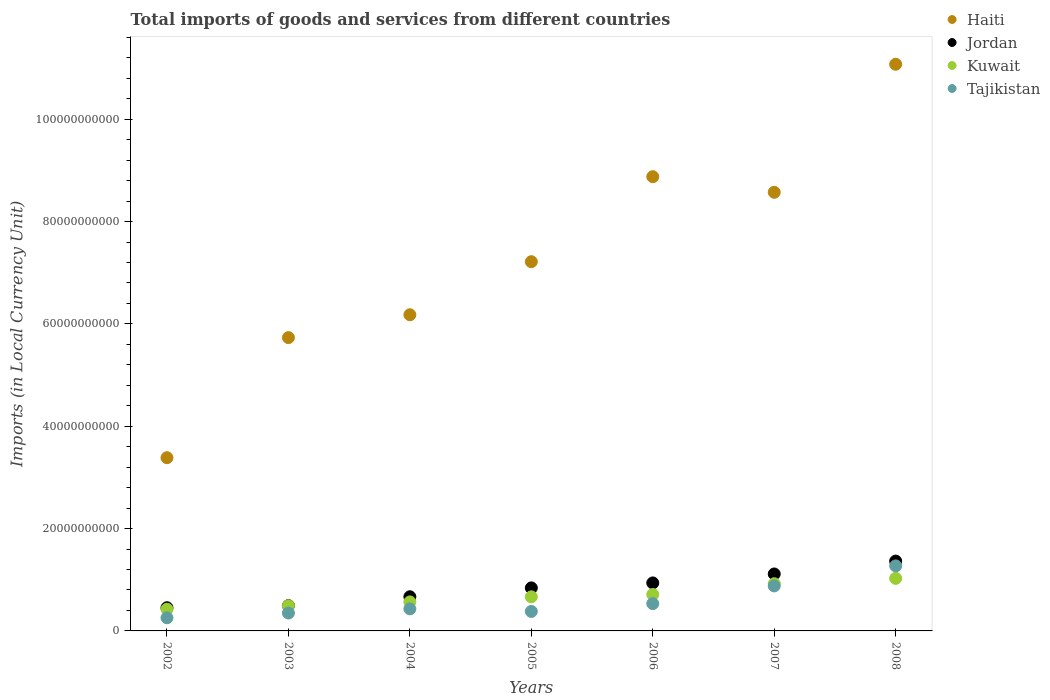Is the number of dotlines equal to the number of legend labels?
Your answer should be compact. Yes. What is the Amount of goods and services imports in Haiti in 2007?
Your response must be concise. 8.57e+1. Across all years, what is the maximum Amount of goods and services imports in Haiti?
Keep it short and to the point. 1.11e+11. Across all years, what is the minimum Amount of goods and services imports in Tajikistan?
Keep it short and to the point. 2.57e+09. In which year was the Amount of goods and services imports in Jordan maximum?
Provide a succinct answer. 2008. In which year was the Amount of goods and services imports in Haiti minimum?
Your answer should be compact. 2002. What is the total Amount of goods and services imports in Haiti in the graph?
Provide a succinct answer. 5.10e+11. What is the difference between the Amount of goods and services imports in Tajikistan in 2003 and that in 2008?
Keep it short and to the point. -9.21e+09. What is the difference between the Amount of goods and services imports in Tajikistan in 2003 and the Amount of goods and services imports in Haiti in 2007?
Your response must be concise. -8.22e+1. What is the average Amount of goods and services imports in Kuwait per year?
Offer a terse response. 6.87e+09. In the year 2006, what is the difference between the Amount of goods and services imports in Jordan and Amount of goods and services imports in Kuwait?
Provide a short and direct response. 2.26e+09. In how many years, is the Amount of goods and services imports in Jordan greater than 88000000000 LCU?
Ensure brevity in your answer.  0. What is the ratio of the Amount of goods and services imports in Tajikistan in 2002 to that in 2007?
Provide a short and direct response. 0.29. Is the difference between the Amount of goods and services imports in Jordan in 2002 and 2004 greater than the difference between the Amount of goods and services imports in Kuwait in 2002 and 2004?
Keep it short and to the point. No. What is the difference between the highest and the second highest Amount of goods and services imports in Haiti?
Your answer should be very brief. 2.20e+1. What is the difference between the highest and the lowest Amount of goods and services imports in Kuwait?
Offer a very short reply. 6.03e+09. Is it the case that in every year, the sum of the Amount of goods and services imports in Kuwait and Amount of goods and services imports in Tajikistan  is greater than the sum of Amount of goods and services imports in Jordan and Amount of goods and services imports in Haiti?
Keep it short and to the point. No. Is the Amount of goods and services imports in Jordan strictly greater than the Amount of goods and services imports in Tajikistan over the years?
Give a very brief answer. Yes. Is the Amount of goods and services imports in Haiti strictly less than the Amount of goods and services imports in Tajikistan over the years?
Provide a short and direct response. No. How many dotlines are there?
Offer a very short reply. 4. What is the difference between two consecutive major ticks on the Y-axis?
Make the answer very short. 2.00e+1. Are the values on the major ticks of Y-axis written in scientific E-notation?
Keep it short and to the point. No. What is the title of the graph?
Your answer should be compact. Total imports of goods and services from different countries. What is the label or title of the Y-axis?
Provide a short and direct response. Imports (in Local Currency Unit). What is the Imports (in Local Currency Unit) in Haiti in 2002?
Make the answer very short. 3.39e+1. What is the Imports (in Local Currency Unit) in Jordan in 2002?
Your answer should be very brief. 4.53e+09. What is the Imports (in Local Currency Unit) in Kuwait in 2002?
Offer a terse response. 4.24e+09. What is the Imports (in Local Currency Unit) of Tajikistan in 2002?
Provide a succinct answer. 2.57e+09. What is the Imports (in Local Currency Unit) in Haiti in 2003?
Make the answer very short. 5.73e+1. What is the Imports (in Local Currency Unit) of Jordan in 2003?
Offer a very short reply. 4.95e+09. What is the Imports (in Local Currency Unit) of Kuwait in 2003?
Offer a terse response. 4.92e+09. What is the Imports (in Local Currency Unit) of Tajikistan in 2003?
Ensure brevity in your answer.  3.50e+09. What is the Imports (in Local Currency Unit) of Haiti in 2004?
Offer a terse response. 6.18e+1. What is the Imports (in Local Currency Unit) in Jordan in 2004?
Provide a short and direct response. 6.68e+09. What is the Imports (in Local Currency Unit) of Kuwait in 2004?
Provide a short and direct response. 5.67e+09. What is the Imports (in Local Currency Unit) of Tajikistan in 2004?
Give a very brief answer. 4.31e+09. What is the Imports (in Local Currency Unit) in Haiti in 2005?
Your answer should be compact. 7.22e+1. What is the Imports (in Local Currency Unit) of Jordan in 2005?
Offer a very short reply. 8.41e+09. What is the Imports (in Local Currency Unit) of Kuwait in 2005?
Your answer should be very brief. 6.67e+09. What is the Imports (in Local Currency Unit) in Tajikistan in 2005?
Your answer should be very brief. 3.81e+09. What is the Imports (in Local Currency Unit) in Haiti in 2006?
Give a very brief answer. 8.88e+1. What is the Imports (in Local Currency Unit) in Jordan in 2006?
Your response must be concise. 9.38e+09. What is the Imports (in Local Currency Unit) of Kuwait in 2006?
Ensure brevity in your answer.  7.12e+09. What is the Imports (in Local Currency Unit) of Tajikistan in 2006?
Offer a very short reply. 5.34e+09. What is the Imports (in Local Currency Unit) of Haiti in 2007?
Offer a very short reply. 8.57e+1. What is the Imports (in Local Currency Unit) of Jordan in 2007?
Your response must be concise. 1.11e+1. What is the Imports (in Local Currency Unit) of Kuwait in 2007?
Keep it short and to the point. 9.23e+09. What is the Imports (in Local Currency Unit) of Tajikistan in 2007?
Offer a terse response. 8.79e+09. What is the Imports (in Local Currency Unit) of Haiti in 2008?
Provide a short and direct response. 1.11e+11. What is the Imports (in Local Currency Unit) of Jordan in 2008?
Provide a short and direct response. 1.36e+1. What is the Imports (in Local Currency Unit) of Kuwait in 2008?
Offer a terse response. 1.03e+1. What is the Imports (in Local Currency Unit) in Tajikistan in 2008?
Offer a very short reply. 1.27e+1. Across all years, what is the maximum Imports (in Local Currency Unit) in Haiti?
Offer a very short reply. 1.11e+11. Across all years, what is the maximum Imports (in Local Currency Unit) of Jordan?
Make the answer very short. 1.36e+1. Across all years, what is the maximum Imports (in Local Currency Unit) in Kuwait?
Your response must be concise. 1.03e+1. Across all years, what is the maximum Imports (in Local Currency Unit) of Tajikistan?
Ensure brevity in your answer.  1.27e+1. Across all years, what is the minimum Imports (in Local Currency Unit) in Haiti?
Your answer should be compact. 3.39e+1. Across all years, what is the minimum Imports (in Local Currency Unit) of Jordan?
Offer a very short reply. 4.53e+09. Across all years, what is the minimum Imports (in Local Currency Unit) in Kuwait?
Offer a terse response. 4.24e+09. Across all years, what is the minimum Imports (in Local Currency Unit) in Tajikistan?
Give a very brief answer. 2.57e+09. What is the total Imports (in Local Currency Unit) in Haiti in the graph?
Offer a very short reply. 5.10e+11. What is the total Imports (in Local Currency Unit) in Jordan in the graph?
Your answer should be very brief. 5.87e+1. What is the total Imports (in Local Currency Unit) of Kuwait in the graph?
Your response must be concise. 4.81e+1. What is the total Imports (in Local Currency Unit) in Tajikistan in the graph?
Give a very brief answer. 4.10e+1. What is the difference between the Imports (in Local Currency Unit) in Haiti in 2002 and that in 2003?
Your answer should be compact. -2.35e+1. What is the difference between the Imports (in Local Currency Unit) of Jordan in 2002 and that in 2003?
Your answer should be very brief. -4.14e+08. What is the difference between the Imports (in Local Currency Unit) in Kuwait in 2002 and that in 2003?
Make the answer very short. -6.74e+08. What is the difference between the Imports (in Local Currency Unit) in Tajikistan in 2002 and that in 2003?
Make the answer very short. -9.28e+08. What is the difference between the Imports (in Local Currency Unit) of Haiti in 2002 and that in 2004?
Offer a terse response. -2.79e+1. What is the difference between the Imports (in Local Currency Unit) of Jordan in 2002 and that in 2004?
Provide a short and direct response. -2.15e+09. What is the difference between the Imports (in Local Currency Unit) in Kuwait in 2002 and that in 2004?
Make the answer very short. -1.43e+09. What is the difference between the Imports (in Local Currency Unit) of Tajikistan in 2002 and that in 2004?
Your answer should be compact. -1.74e+09. What is the difference between the Imports (in Local Currency Unit) in Haiti in 2002 and that in 2005?
Give a very brief answer. -3.83e+1. What is the difference between the Imports (in Local Currency Unit) in Jordan in 2002 and that in 2005?
Provide a succinct answer. -3.88e+09. What is the difference between the Imports (in Local Currency Unit) in Kuwait in 2002 and that in 2005?
Offer a terse response. -2.43e+09. What is the difference between the Imports (in Local Currency Unit) in Tajikistan in 2002 and that in 2005?
Provide a short and direct response. -1.24e+09. What is the difference between the Imports (in Local Currency Unit) of Haiti in 2002 and that in 2006?
Your answer should be compact. -5.49e+1. What is the difference between the Imports (in Local Currency Unit) of Jordan in 2002 and that in 2006?
Offer a terse response. -4.85e+09. What is the difference between the Imports (in Local Currency Unit) of Kuwait in 2002 and that in 2006?
Make the answer very short. -2.88e+09. What is the difference between the Imports (in Local Currency Unit) in Tajikistan in 2002 and that in 2006?
Provide a short and direct response. -2.77e+09. What is the difference between the Imports (in Local Currency Unit) in Haiti in 2002 and that in 2007?
Make the answer very short. -5.19e+1. What is the difference between the Imports (in Local Currency Unit) of Jordan in 2002 and that in 2007?
Provide a short and direct response. -6.60e+09. What is the difference between the Imports (in Local Currency Unit) of Kuwait in 2002 and that in 2007?
Provide a short and direct response. -4.98e+09. What is the difference between the Imports (in Local Currency Unit) in Tajikistan in 2002 and that in 2007?
Your answer should be compact. -6.23e+09. What is the difference between the Imports (in Local Currency Unit) in Haiti in 2002 and that in 2008?
Offer a very short reply. -7.69e+1. What is the difference between the Imports (in Local Currency Unit) in Jordan in 2002 and that in 2008?
Ensure brevity in your answer.  -9.11e+09. What is the difference between the Imports (in Local Currency Unit) of Kuwait in 2002 and that in 2008?
Your response must be concise. -6.03e+09. What is the difference between the Imports (in Local Currency Unit) of Tajikistan in 2002 and that in 2008?
Make the answer very short. -1.01e+1. What is the difference between the Imports (in Local Currency Unit) in Haiti in 2003 and that in 2004?
Your answer should be compact. -4.47e+09. What is the difference between the Imports (in Local Currency Unit) of Jordan in 2003 and that in 2004?
Make the answer very short. -1.73e+09. What is the difference between the Imports (in Local Currency Unit) in Kuwait in 2003 and that in 2004?
Your answer should be compact. -7.55e+08. What is the difference between the Imports (in Local Currency Unit) of Tajikistan in 2003 and that in 2004?
Offer a terse response. -8.15e+08. What is the difference between the Imports (in Local Currency Unit) in Haiti in 2003 and that in 2005?
Provide a succinct answer. -1.48e+1. What is the difference between the Imports (in Local Currency Unit) in Jordan in 2003 and that in 2005?
Ensure brevity in your answer.  -3.46e+09. What is the difference between the Imports (in Local Currency Unit) of Kuwait in 2003 and that in 2005?
Keep it short and to the point. -1.75e+09. What is the difference between the Imports (in Local Currency Unit) in Tajikistan in 2003 and that in 2005?
Keep it short and to the point. -3.09e+08. What is the difference between the Imports (in Local Currency Unit) of Haiti in 2003 and that in 2006?
Offer a terse response. -3.15e+1. What is the difference between the Imports (in Local Currency Unit) of Jordan in 2003 and that in 2006?
Provide a short and direct response. -4.44e+09. What is the difference between the Imports (in Local Currency Unit) of Kuwait in 2003 and that in 2006?
Give a very brief answer. -2.20e+09. What is the difference between the Imports (in Local Currency Unit) in Tajikistan in 2003 and that in 2006?
Keep it short and to the point. -1.84e+09. What is the difference between the Imports (in Local Currency Unit) of Haiti in 2003 and that in 2007?
Give a very brief answer. -2.84e+1. What is the difference between the Imports (in Local Currency Unit) of Jordan in 2003 and that in 2007?
Give a very brief answer. -6.19e+09. What is the difference between the Imports (in Local Currency Unit) of Kuwait in 2003 and that in 2007?
Offer a terse response. -4.31e+09. What is the difference between the Imports (in Local Currency Unit) in Tajikistan in 2003 and that in 2007?
Make the answer very short. -5.30e+09. What is the difference between the Imports (in Local Currency Unit) of Haiti in 2003 and that in 2008?
Your answer should be compact. -5.34e+1. What is the difference between the Imports (in Local Currency Unit) in Jordan in 2003 and that in 2008?
Offer a terse response. -8.70e+09. What is the difference between the Imports (in Local Currency Unit) in Kuwait in 2003 and that in 2008?
Provide a short and direct response. -5.35e+09. What is the difference between the Imports (in Local Currency Unit) of Tajikistan in 2003 and that in 2008?
Give a very brief answer. -9.21e+09. What is the difference between the Imports (in Local Currency Unit) in Haiti in 2004 and that in 2005?
Offer a terse response. -1.04e+1. What is the difference between the Imports (in Local Currency Unit) of Jordan in 2004 and that in 2005?
Make the answer very short. -1.73e+09. What is the difference between the Imports (in Local Currency Unit) of Kuwait in 2004 and that in 2005?
Provide a succinct answer. -9.97e+08. What is the difference between the Imports (in Local Currency Unit) of Tajikistan in 2004 and that in 2005?
Provide a succinct answer. 5.06e+08. What is the difference between the Imports (in Local Currency Unit) of Haiti in 2004 and that in 2006?
Make the answer very short. -2.70e+1. What is the difference between the Imports (in Local Currency Unit) in Jordan in 2004 and that in 2006?
Ensure brevity in your answer.  -2.70e+09. What is the difference between the Imports (in Local Currency Unit) of Kuwait in 2004 and that in 2006?
Provide a short and direct response. -1.45e+09. What is the difference between the Imports (in Local Currency Unit) in Tajikistan in 2004 and that in 2006?
Give a very brief answer. -1.02e+09. What is the difference between the Imports (in Local Currency Unit) in Haiti in 2004 and that in 2007?
Your response must be concise. -2.39e+1. What is the difference between the Imports (in Local Currency Unit) in Jordan in 2004 and that in 2007?
Your response must be concise. -4.45e+09. What is the difference between the Imports (in Local Currency Unit) in Kuwait in 2004 and that in 2007?
Your response must be concise. -3.55e+09. What is the difference between the Imports (in Local Currency Unit) of Tajikistan in 2004 and that in 2007?
Your response must be concise. -4.48e+09. What is the difference between the Imports (in Local Currency Unit) of Haiti in 2004 and that in 2008?
Ensure brevity in your answer.  -4.90e+1. What is the difference between the Imports (in Local Currency Unit) in Jordan in 2004 and that in 2008?
Keep it short and to the point. -6.97e+09. What is the difference between the Imports (in Local Currency Unit) of Kuwait in 2004 and that in 2008?
Make the answer very short. -4.60e+09. What is the difference between the Imports (in Local Currency Unit) in Tajikistan in 2004 and that in 2008?
Provide a short and direct response. -8.40e+09. What is the difference between the Imports (in Local Currency Unit) in Haiti in 2005 and that in 2006?
Offer a terse response. -1.66e+1. What is the difference between the Imports (in Local Currency Unit) in Jordan in 2005 and that in 2006?
Make the answer very short. -9.72e+08. What is the difference between the Imports (in Local Currency Unit) in Kuwait in 2005 and that in 2006?
Ensure brevity in your answer.  -4.53e+08. What is the difference between the Imports (in Local Currency Unit) of Tajikistan in 2005 and that in 2006?
Provide a succinct answer. -1.53e+09. What is the difference between the Imports (in Local Currency Unit) in Haiti in 2005 and that in 2007?
Offer a very short reply. -1.36e+1. What is the difference between the Imports (in Local Currency Unit) in Jordan in 2005 and that in 2007?
Provide a succinct answer. -2.72e+09. What is the difference between the Imports (in Local Currency Unit) of Kuwait in 2005 and that in 2007?
Your answer should be very brief. -2.56e+09. What is the difference between the Imports (in Local Currency Unit) in Tajikistan in 2005 and that in 2007?
Ensure brevity in your answer.  -4.99e+09. What is the difference between the Imports (in Local Currency Unit) of Haiti in 2005 and that in 2008?
Give a very brief answer. -3.86e+1. What is the difference between the Imports (in Local Currency Unit) of Jordan in 2005 and that in 2008?
Provide a short and direct response. -5.24e+09. What is the difference between the Imports (in Local Currency Unit) in Kuwait in 2005 and that in 2008?
Make the answer very short. -3.60e+09. What is the difference between the Imports (in Local Currency Unit) in Tajikistan in 2005 and that in 2008?
Keep it short and to the point. -8.90e+09. What is the difference between the Imports (in Local Currency Unit) in Haiti in 2006 and that in 2007?
Your response must be concise. 3.05e+09. What is the difference between the Imports (in Local Currency Unit) in Jordan in 2006 and that in 2007?
Offer a very short reply. -1.75e+09. What is the difference between the Imports (in Local Currency Unit) of Kuwait in 2006 and that in 2007?
Provide a succinct answer. -2.10e+09. What is the difference between the Imports (in Local Currency Unit) of Tajikistan in 2006 and that in 2007?
Provide a succinct answer. -3.46e+09. What is the difference between the Imports (in Local Currency Unit) of Haiti in 2006 and that in 2008?
Your answer should be very brief. -2.20e+1. What is the difference between the Imports (in Local Currency Unit) in Jordan in 2006 and that in 2008?
Keep it short and to the point. -4.27e+09. What is the difference between the Imports (in Local Currency Unit) in Kuwait in 2006 and that in 2008?
Your answer should be compact. -3.15e+09. What is the difference between the Imports (in Local Currency Unit) of Tajikistan in 2006 and that in 2008?
Your response must be concise. -7.37e+09. What is the difference between the Imports (in Local Currency Unit) in Haiti in 2007 and that in 2008?
Provide a succinct answer. -2.50e+1. What is the difference between the Imports (in Local Currency Unit) in Jordan in 2007 and that in 2008?
Your answer should be compact. -2.51e+09. What is the difference between the Imports (in Local Currency Unit) of Kuwait in 2007 and that in 2008?
Make the answer very short. -1.04e+09. What is the difference between the Imports (in Local Currency Unit) in Tajikistan in 2007 and that in 2008?
Provide a short and direct response. -3.91e+09. What is the difference between the Imports (in Local Currency Unit) in Haiti in 2002 and the Imports (in Local Currency Unit) in Jordan in 2003?
Offer a terse response. 2.89e+1. What is the difference between the Imports (in Local Currency Unit) of Haiti in 2002 and the Imports (in Local Currency Unit) of Kuwait in 2003?
Your answer should be compact. 2.89e+1. What is the difference between the Imports (in Local Currency Unit) of Haiti in 2002 and the Imports (in Local Currency Unit) of Tajikistan in 2003?
Give a very brief answer. 3.04e+1. What is the difference between the Imports (in Local Currency Unit) of Jordan in 2002 and the Imports (in Local Currency Unit) of Kuwait in 2003?
Ensure brevity in your answer.  -3.86e+08. What is the difference between the Imports (in Local Currency Unit) in Jordan in 2002 and the Imports (in Local Currency Unit) in Tajikistan in 2003?
Provide a succinct answer. 1.03e+09. What is the difference between the Imports (in Local Currency Unit) of Kuwait in 2002 and the Imports (in Local Currency Unit) of Tajikistan in 2003?
Your answer should be compact. 7.47e+08. What is the difference between the Imports (in Local Currency Unit) of Haiti in 2002 and the Imports (in Local Currency Unit) of Jordan in 2004?
Give a very brief answer. 2.72e+1. What is the difference between the Imports (in Local Currency Unit) in Haiti in 2002 and the Imports (in Local Currency Unit) in Kuwait in 2004?
Provide a short and direct response. 2.82e+1. What is the difference between the Imports (in Local Currency Unit) of Haiti in 2002 and the Imports (in Local Currency Unit) of Tajikistan in 2004?
Your response must be concise. 2.95e+1. What is the difference between the Imports (in Local Currency Unit) of Jordan in 2002 and the Imports (in Local Currency Unit) of Kuwait in 2004?
Make the answer very short. -1.14e+09. What is the difference between the Imports (in Local Currency Unit) of Jordan in 2002 and the Imports (in Local Currency Unit) of Tajikistan in 2004?
Make the answer very short. 2.20e+08. What is the difference between the Imports (in Local Currency Unit) of Kuwait in 2002 and the Imports (in Local Currency Unit) of Tajikistan in 2004?
Your answer should be compact. -6.84e+07. What is the difference between the Imports (in Local Currency Unit) in Haiti in 2002 and the Imports (in Local Currency Unit) in Jordan in 2005?
Offer a very short reply. 2.54e+1. What is the difference between the Imports (in Local Currency Unit) in Haiti in 2002 and the Imports (in Local Currency Unit) in Kuwait in 2005?
Your answer should be compact. 2.72e+1. What is the difference between the Imports (in Local Currency Unit) of Haiti in 2002 and the Imports (in Local Currency Unit) of Tajikistan in 2005?
Provide a short and direct response. 3.00e+1. What is the difference between the Imports (in Local Currency Unit) in Jordan in 2002 and the Imports (in Local Currency Unit) in Kuwait in 2005?
Offer a very short reply. -2.14e+09. What is the difference between the Imports (in Local Currency Unit) of Jordan in 2002 and the Imports (in Local Currency Unit) of Tajikistan in 2005?
Your answer should be very brief. 7.26e+08. What is the difference between the Imports (in Local Currency Unit) in Kuwait in 2002 and the Imports (in Local Currency Unit) in Tajikistan in 2005?
Your answer should be very brief. 4.38e+08. What is the difference between the Imports (in Local Currency Unit) in Haiti in 2002 and the Imports (in Local Currency Unit) in Jordan in 2006?
Provide a succinct answer. 2.45e+1. What is the difference between the Imports (in Local Currency Unit) in Haiti in 2002 and the Imports (in Local Currency Unit) in Kuwait in 2006?
Your answer should be very brief. 2.67e+1. What is the difference between the Imports (in Local Currency Unit) of Haiti in 2002 and the Imports (in Local Currency Unit) of Tajikistan in 2006?
Provide a succinct answer. 2.85e+1. What is the difference between the Imports (in Local Currency Unit) of Jordan in 2002 and the Imports (in Local Currency Unit) of Kuwait in 2006?
Provide a succinct answer. -2.59e+09. What is the difference between the Imports (in Local Currency Unit) of Jordan in 2002 and the Imports (in Local Currency Unit) of Tajikistan in 2006?
Offer a terse response. -8.05e+08. What is the difference between the Imports (in Local Currency Unit) of Kuwait in 2002 and the Imports (in Local Currency Unit) of Tajikistan in 2006?
Provide a short and direct response. -1.09e+09. What is the difference between the Imports (in Local Currency Unit) of Haiti in 2002 and the Imports (in Local Currency Unit) of Jordan in 2007?
Provide a short and direct response. 2.27e+1. What is the difference between the Imports (in Local Currency Unit) in Haiti in 2002 and the Imports (in Local Currency Unit) in Kuwait in 2007?
Your answer should be compact. 2.46e+1. What is the difference between the Imports (in Local Currency Unit) in Haiti in 2002 and the Imports (in Local Currency Unit) in Tajikistan in 2007?
Make the answer very short. 2.51e+1. What is the difference between the Imports (in Local Currency Unit) in Jordan in 2002 and the Imports (in Local Currency Unit) in Kuwait in 2007?
Your answer should be very brief. -4.69e+09. What is the difference between the Imports (in Local Currency Unit) of Jordan in 2002 and the Imports (in Local Currency Unit) of Tajikistan in 2007?
Your response must be concise. -4.26e+09. What is the difference between the Imports (in Local Currency Unit) of Kuwait in 2002 and the Imports (in Local Currency Unit) of Tajikistan in 2007?
Your response must be concise. -4.55e+09. What is the difference between the Imports (in Local Currency Unit) in Haiti in 2002 and the Imports (in Local Currency Unit) in Jordan in 2008?
Your response must be concise. 2.02e+1. What is the difference between the Imports (in Local Currency Unit) in Haiti in 2002 and the Imports (in Local Currency Unit) in Kuwait in 2008?
Your answer should be compact. 2.36e+1. What is the difference between the Imports (in Local Currency Unit) in Haiti in 2002 and the Imports (in Local Currency Unit) in Tajikistan in 2008?
Your answer should be very brief. 2.11e+1. What is the difference between the Imports (in Local Currency Unit) of Jordan in 2002 and the Imports (in Local Currency Unit) of Kuwait in 2008?
Keep it short and to the point. -5.74e+09. What is the difference between the Imports (in Local Currency Unit) of Jordan in 2002 and the Imports (in Local Currency Unit) of Tajikistan in 2008?
Keep it short and to the point. -8.18e+09. What is the difference between the Imports (in Local Currency Unit) in Kuwait in 2002 and the Imports (in Local Currency Unit) in Tajikistan in 2008?
Ensure brevity in your answer.  -8.46e+09. What is the difference between the Imports (in Local Currency Unit) in Haiti in 2003 and the Imports (in Local Currency Unit) in Jordan in 2004?
Offer a terse response. 5.06e+1. What is the difference between the Imports (in Local Currency Unit) of Haiti in 2003 and the Imports (in Local Currency Unit) of Kuwait in 2004?
Provide a succinct answer. 5.16e+1. What is the difference between the Imports (in Local Currency Unit) of Haiti in 2003 and the Imports (in Local Currency Unit) of Tajikistan in 2004?
Provide a succinct answer. 5.30e+1. What is the difference between the Imports (in Local Currency Unit) in Jordan in 2003 and the Imports (in Local Currency Unit) in Kuwait in 2004?
Provide a short and direct response. -7.27e+08. What is the difference between the Imports (in Local Currency Unit) of Jordan in 2003 and the Imports (in Local Currency Unit) of Tajikistan in 2004?
Give a very brief answer. 6.34e+08. What is the difference between the Imports (in Local Currency Unit) of Kuwait in 2003 and the Imports (in Local Currency Unit) of Tajikistan in 2004?
Provide a succinct answer. 6.06e+08. What is the difference between the Imports (in Local Currency Unit) of Haiti in 2003 and the Imports (in Local Currency Unit) of Jordan in 2005?
Offer a terse response. 4.89e+1. What is the difference between the Imports (in Local Currency Unit) of Haiti in 2003 and the Imports (in Local Currency Unit) of Kuwait in 2005?
Make the answer very short. 5.06e+1. What is the difference between the Imports (in Local Currency Unit) of Haiti in 2003 and the Imports (in Local Currency Unit) of Tajikistan in 2005?
Provide a short and direct response. 5.35e+1. What is the difference between the Imports (in Local Currency Unit) in Jordan in 2003 and the Imports (in Local Currency Unit) in Kuwait in 2005?
Ensure brevity in your answer.  -1.72e+09. What is the difference between the Imports (in Local Currency Unit) in Jordan in 2003 and the Imports (in Local Currency Unit) in Tajikistan in 2005?
Make the answer very short. 1.14e+09. What is the difference between the Imports (in Local Currency Unit) of Kuwait in 2003 and the Imports (in Local Currency Unit) of Tajikistan in 2005?
Your response must be concise. 1.11e+09. What is the difference between the Imports (in Local Currency Unit) in Haiti in 2003 and the Imports (in Local Currency Unit) in Jordan in 2006?
Your response must be concise. 4.79e+1. What is the difference between the Imports (in Local Currency Unit) of Haiti in 2003 and the Imports (in Local Currency Unit) of Kuwait in 2006?
Your answer should be compact. 5.02e+1. What is the difference between the Imports (in Local Currency Unit) in Haiti in 2003 and the Imports (in Local Currency Unit) in Tajikistan in 2006?
Your answer should be very brief. 5.20e+1. What is the difference between the Imports (in Local Currency Unit) in Jordan in 2003 and the Imports (in Local Currency Unit) in Kuwait in 2006?
Offer a terse response. -2.18e+09. What is the difference between the Imports (in Local Currency Unit) in Jordan in 2003 and the Imports (in Local Currency Unit) in Tajikistan in 2006?
Ensure brevity in your answer.  -3.91e+08. What is the difference between the Imports (in Local Currency Unit) in Kuwait in 2003 and the Imports (in Local Currency Unit) in Tajikistan in 2006?
Give a very brief answer. -4.19e+08. What is the difference between the Imports (in Local Currency Unit) of Haiti in 2003 and the Imports (in Local Currency Unit) of Jordan in 2007?
Keep it short and to the point. 4.62e+1. What is the difference between the Imports (in Local Currency Unit) in Haiti in 2003 and the Imports (in Local Currency Unit) in Kuwait in 2007?
Offer a terse response. 4.81e+1. What is the difference between the Imports (in Local Currency Unit) in Haiti in 2003 and the Imports (in Local Currency Unit) in Tajikistan in 2007?
Make the answer very short. 4.85e+1. What is the difference between the Imports (in Local Currency Unit) of Jordan in 2003 and the Imports (in Local Currency Unit) of Kuwait in 2007?
Offer a terse response. -4.28e+09. What is the difference between the Imports (in Local Currency Unit) of Jordan in 2003 and the Imports (in Local Currency Unit) of Tajikistan in 2007?
Ensure brevity in your answer.  -3.85e+09. What is the difference between the Imports (in Local Currency Unit) of Kuwait in 2003 and the Imports (in Local Currency Unit) of Tajikistan in 2007?
Keep it short and to the point. -3.88e+09. What is the difference between the Imports (in Local Currency Unit) of Haiti in 2003 and the Imports (in Local Currency Unit) of Jordan in 2008?
Offer a very short reply. 4.37e+1. What is the difference between the Imports (in Local Currency Unit) of Haiti in 2003 and the Imports (in Local Currency Unit) of Kuwait in 2008?
Ensure brevity in your answer.  4.70e+1. What is the difference between the Imports (in Local Currency Unit) of Haiti in 2003 and the Imports (in Local Currency Unit) of Tajikistan in 2008?
Make the answer very short. 4.46e+1. What is the difference between the Imports (in Local Currency Unit) of Jordan in 2003 and the Imports (in Local Currency Unit) of Kuwait in 2008?
Ensure brevity in your answer.  -5.33e+09. What is the difference between the Imports (in Local Currency Unit) of Jordan in 2003 and the Imports (in Local Currency Unit) of Tajikistan in 2008?
Your answer should be very brief. -7.76e+09. What is the difference between the Imports (in Local Currency Unit) of Kuwait in 2003 and the Imports (in Local Currency Unit) of Tajikistan in 2008?
Keep it short and to the point. -7.79e+09. What is the difference between the Imports (in Local Currency Unit) in Haiti in 2004 and the Imports (in Local Currency Unit) in Jordan in 2005?
Ensure brevity in your answer.  5.34e+1. What is the difference between the Imports (in Local Currency Unit) in Haiti in 2004 and the Imports (in Local Currency Unit) in Kuwait in 2005?
Provide a short and direct response. 5.51e+1. What is the difference between the Imports (in Local Currency Unit) in Haiti in 2004 and the Imports (in Local Currency Unit) in Tajikistan in 2005?
Give a very brief answer. 5.80e+1. What is the difference between the Imports (in Local Currency Unit) of Jordan in 2004 and the Imports (in Local Currency Unit) of Kuwait in 2005?
Your answer should be very brief. 7.89e+06. What is the difference between the Imports (in Local Currency Unit) in Jordan in 2004 and the Imports (in Local Currency Unit) in Tajikistan in 2005?
Your answer should be compact. 2.87e+09. What is the difference between the Imports (in Local Currency Unit) in Kuwait in 2004 and the Imports (in Local Currency Unit) in Tajikistan in 2005?
Keep it short and to the point. 1.87e+09. What is the difference between the Imports (in Local Currency Unit) in Haiti in 2004 and the Imports (in Local Currency Unit) in Jordan in 2006?
Provide a succinct answer. 5.24e+1. What is the difference between the Imports (in Local Currency Unit) of Haiti in 2004 and the Imports (in Local Currency Unit) of Kuwait in 2006?
Offer a very short reply. 5.47e+1. What is the difference between the Imports (in Local Currency Unit) of Haiti in 2004 and the Imports (in Local Currency Unit) of Tajikistan in 2006?
Keep it short and to the point. 5.64e+1. What is the difference between the Imports (in Local Currency Unit) of Jordan in 2004 and the Imports (in Local Currency Unit) of Kuwait in 2006?
Ensure brevity in your answer.  -4.45e+08. What is the difference between the Imports (in Local Currency Unit) in Jordan in 2004 and the Imports (in Local Currency Unit) in Tajikistan in 2006?
Give a very brief answer. 1.34e+09. What is the difference between the Imports (in Local Currency Unit) of Kuwait in 2004 and the Imports (in Local Currency Unit) of Tajikistan in 2006?
Keep it short and to the point. 3.36e+08. What is the difference between the Imports (in Local Currency Unit) of Haiti in 2004 and the Imports (in Local Currency Unit) of Jordan in 2007?
Keep it short and to the point. 5.07e+1. What is the difference between the Imports (in Local Currency Unit) of Haiti in 2004 and the Imports (in Local Currency Unit) of Kuwait in 2007?
Offer a terse response. 5.26e+1. What is the difference between the Imports (in Local Currency Unit) of Haiti in 2004 and the Imports (in Local Currency Unit) of Tajikistan in 2007?
Offer a terse response. 5.30e+1. What is the difference between the Imports (in Local Currency Unit) in Jordan in 2004 and the Imports (in Local Currency Unit) in Kuwait in 2007?
Your answer should be very brief. -2.55e+09. What is the difference between the Imports (in Local Currency Unit) in Jordan in 2004 and the Imports (in Local Currency Unit) in Tajikistan in 2007?
Keep it short and to the point. -2.12e+09. What is the difference between the Imports (in Local Currency Unit) of Kuwait in 2004 and the Imports (in Local Currency Unit) of Tajikistan in 2007?
Give a very brief answer. -3.12e+09. What is the difference between the Imports (in Local Currency Unit) of Haiti in 2004 and the Imports (in Local Currency Unit) of Jordan in 2008?
Keep it short and to the point. 4.81e+1. What is the difference between the Imports (in Local Currency Unit) in Haiti in 2004 and the Imports (in Local Currency Unit) in Kuwait in 2008?
Make the answer very short. 5.15e+1. What is the difference between the Imports (in Local Currency Unit) of Haiti in 2004 and the Imports (in Local Currency Unit) of Tajikistan in 2008?
Your answer should be very brief. 4.91e+1. What is the difference between the Imports (in Local Currency Unit) in Jordan in 2004 and the Imports (in Local Currency Unit) in Kuwait in 2008?
Make the answer very short. -3.59e+09. What is the difference between the Imports (in Local Currency Unit) in Jordan in 2004 and the Imports (in Local Currency Unit) in Tajikistan in 2008?
Your answer should be compact. -6.03e+09. What is the difference between the Imports (in Local Currency Unit) in Kuwait in 2004 and the Imports (in Local Currency Unit) in Tajikistan in 2008?
Give a very brief answer. -7.04e+09. What is the difference between the Imports (in Local Currency Unit) of Haiti in 2005 and the Imports (in Local Currency Unit) of Jordan in 2006?
Provide a short and direct response. 6.28e+1. What is the difference between the Imports (in Local Currency Unit) in Haiti in 2005 and the Imports (in Local Currency Unit) in Kuwait in 2006?
Offer a terse response. 6.50e+1. What is the difference between the Imports (in Local Currency Unit) of Haiti in 2005 and the Imports (in Local Currency Unit) of Tajikistan in 2006?
Your answer should be very brief. 6.68e+1. What is the difference between the Imports (in Local Currency Unit) of Jordan in 2005 and the Imports (in Local Currency Unit) of Kuwait in 2006?
Keep it short and to the point. 1.29e+09. What is the difference between the Imports (in Local Currency Unit) of Jordan in 2005 and the Imports (in Local Currency Unit) of Tajikistan in 2006?
Provide a short and direct response. 3.07e+09. What is the difference between the Imports (in Local Currency Unit) of Kuwait in 2005 and the Imports (in Local Currency Unit) of Tajikistan in 2006?
Keep it short and to the point. 1.33e+09. What is the difference between the Imports (in Local Currency Unit) of Haiti in 2005 and the Imports (in Local Currency Unit) of Jordan in 2007?
Provide a succinct answer. 6.10e+1. What is the difference between the Imports (in Local Currency Unit) in Haiti in 2005 and the Imports (in Local Currency Unit) in Kuwait in 2007?
Offer a terse response. 6.29e+1. What is the difference between the Imports (in Local Currency Unit) of Haiti in 2005 and the Imports (in Local Currency Unit) of Tajikistan in 2007?
Your answer should be compact. 6.34e+1. What is the difference between the Imports (in Local Currency Unit) of Jordan in 2005 and the Imports (in Local Currency Unit) of Kuwait in 2007?
Your answer should be very brief. -8.18e+08. What is the difference between the Imports (in Local Currency Unit) of Jordan in 2005 and the Imports (in Local Currency Unit) of Tajikistan in 2007?
Offer a terse response. -3.87e+08. What is the difference between the Imports (in Local Currency Unit) in Kuwait in 2005 and the Imports (in Local Currency Unit) in Tajikistan in 2007?
Give a very brief answer. -2.13e+09. What is the difference between the Imports (in Local Currency Unit) of Haiti in 2005 and the Imports (in Local Currency Unit) of Jordan in 2008?
Make the answer very short. 5.85e+1. What is the difference between the Imports (in Local Currency Unit) in Haiti in 2005 and the Imports (in Local Currency Unit) in Kuwait in 2008?
Offer a very short reply. 6.19e+1. What is the difference between the Imports (in Local Currency Unit) in Haiti in 2005 and the Imports (in Local Currency Unit) in Tajikistan in 2008?
Your answer should be compact. 5.94e+1. What is the difference between the Imports (in Local Currency Unit) in Jordan in 2005 and the Imports (in Local Currency Unit) in Kuwait in 2008?
Your answer should be very brief. -1.86e+09. What is the difference between the Imports (in Local Currency Unit) of Jordan in 2005 and the Imports (in Local Currency Unit) of Tajikistan in 2008?
Offer a terse response. -4.30e+09. What is the difference between the Imports (in Local Currency Unit) in Kuwait in 2005 and the Imports (in Local Currency Unit) in Tajikistan in 2008?
Ensure brevity in your answer.  -6.04e+09. What is the difference between the Imports (in Local Currency Unit) of Haiti in 2006 and the Imports (in Local Currency Unit) of Jordan in 2007?
Your answer should be compact. 7.76e+1. What is the difference between the Imports (in Local Currency Unit) of Haiti in 2006 and the Imports (in Local Currency Unit) of Kuwait in 2007?
Offer a terse response. 7.95e+1. What is the difference between the Imports (in Local Currency Unit) of Haiti in 2006 and the Imports (in Local Currency Unit) of Tajikistan in 2007?
Give a very brief answer. 8.00e+1. What is the difference between the Imports (in Local Currency Unit) of Jordan in 2006 and the Imports (in Local Currency Unit) of Kuwait in 2007?
Your response must be concise. 1.55e+08. What is the difference between the Imports (in Local Currency Unit) of Jordan in 2006 and the Imports (in Local Currency Unit) of Tajikistan in 2007?
Offer a terse response. 5.86e+08. What is the difference between the Imports (in Local Currency Unit) in Kuwait in 2006 and the Imports (in Local Currency Unit) in Tajikistan in 2007?
Make the answer very short. -1.67e+09. What is the difference between the Imports (in Local Currency Unit) in Haiti in 2006 and the Imports (in Local Currency Unit) in Jordan in 2008?
Keep it short and to the point. 7.51e+1. What is the difference between the Imports (in Local Currency Unit) of Haiti in 2006 and the Imports (in Local Currency Unit) of Kuwait in 2008?
Your answer should be very brief. 7.85e+1. What is the difference between the Imports (in Local Currency Unit) of Haiti in 2006 and the Imports (in Local Currency Unit) of Tajikistan in 2008?
Your response must be concise. 7.61e+1. What is the difference between the Imports (in Local Currency Unit) in Jordan in 2006 and the Imports (in Local Currency Unit) in Kuwait in 2008?
Provide a succinct answer. -8.90e+08. What is the difference between the Imports (in Local Currency Unit) of Jordan in 2006 and the Imports (in Local Currency Unit) of Tajikistan in 2008?
Offer a terse response. -3.33e+09. What is the difference between the Imports (in Local Currency Unit) in Kuwait in 2006 and the Imports (in Local Currency Unit) in Tajikistan in 2008?
Your answer should be very brief. -5.59e+09. What is the difference between the Imports (in Local Currency Unit) of Haiti in 2007 and the Imports (in Local Currency Unit) of Jordan in 2008?
Make the answer very short. 7.21e+1. What is the difference between the Imports (in Local Currency Unit) in Haiti in 2007 and the Imports (in Local Currency Unit) in Kuwait in 2008?
Your response must be concise. 7.54e+1. What is the difference between the Imports (in Local Currency Unit) of Haiti in 2007 and the Imports (in Local Currency Unit) of Tajikistan in 2008?
Your answer should be very brief. 7.30e+1. What is the difference between the Imports (in Local Currency Unit) of Jordan in 2007 and the Imports (in Local Currency Unit) of Kuwait in 2008?
Make the answer very short. 8.61e+08. What is the difference between the Imports (in Local Currency Unit) of Jordan in 2007 and the Imports (in Local Currency Unit) of Tajikistan in 2008?
Keep it short and to the point. -1.58e+09. What is the difference between the Imports (in Local Currency Unit) in Kuwait in 2007 and the Imports (in Local Currency Unit) in Tajikistan in 2008?
Ensure brevity in your answer.  -3.48e+09. What is the average Imports (in Local Currency Unit) in Haiti per year?
Provide a succinct answer. 7.29e+1. What is the average Imports (in Local Currency Unit) in Jordan per year?
Provide a short and direct response. 8.39e+09. What is the average Imports (in Local Currency Unit) in Kuwait per year?
Make the answer very short. 6.87e+09. What is the average Imports (in Local Currency Unit) in Tajikistan per year?
Keep it short and to the point. 5.86e+09. In the year 2002, what is the difference between the Imports (in Local Currency Unit) in Haiti and Imports (in Local Currency Unit) in Jordan?
Keep it short and to the point. 2.93e+1. In the year 2002, what is the difference between the Imports (in Local Currency Unit) in Haiti and Imports (in Local Currency Unit) in Kuwait?
Provide a short and direct response. 2.96e+1. In the year 2002, what is the difference between the Imports (in Local Currency Unit) of Haiti and Imports (in Local Currency Unit) of Tajikistan?
Your response must be concise. 3.13e+1. In the year 2002, what is the difference between the Imports (in Local Currency Unit) in Jordan and Imports (in Local Currency Unit) in Kuwait?
Your response must be concise. 2.88e+08. In the year 2002, what is the difference between the Imports (in Local Currency Unit) in Jordan and Imports (in Local Currency Unit) in Tajikistan?
Your answer should be compact. 1.96e+09. In the year 2002, what is the difference between the Imports (in Local Currency Unit) of Kuwait and Imports (in Local Currency Unit) of Tajikistan?
Offer a terse response. 1.67e+09. In the year 2003, what is the difference between the Imports (in Local Currency Unit) of Haiti and Imports (in Local Currency Unit) of Jordan?
Give a very brief answer. 5.24e+1. In the year 2003, what is the difference between the Imports (in Local Currency Unit) in Haiti and Imports (in Local Currency Unit) in Kuwait?
Give a very brief answer. 5.24e+1. In the year 2003, what is the difference between the Imports (in Local Currency Unit) in Haiti and Imports (in Local Currency Unit) in Tajikistan?
Your response must be concise. 5.38e+1. In the year 2003, what is the difference between the Imports (in Local Currency Unit) of Jordan and Imports (in Local Currency Unit) of Kuwait?
Ensure brevity in your answer.  2.82e+07. In the year 2003, what is the difference between the Imports (in Local Currency Unit) of Jordan and Imports (in Local Currency Unit) of Tajikistan?
Your response must be concise. 1.45e+09. In the year 2003, what is the difference between the Imports (in Local Currency Unit) of Kuwait and Imports (in Local Currency Unit) of Tajikistan?
Offer a very short reply. 1.42e+09. In the year 2004, what is the difference between the Imports (in Local Currency Unit) of Haiti and Imports (in Local Currency Unit) of Jordan?
Your response must be concise. 5.51e+1. In the year 2004, what is the difference between the Imports (in Local Currency Unit) in Haiti and Imports (in Local Currency Unit) in Kuwait?
Your response must be concise. 5.61e+1. In the year 2004, what is the difference between the Imports (in Local Currency Unit) in Haiti and Imports (in Local Currency Unit) in Tajikistan?
Offer a very short reply. 5.75e+1. In the year 2004, what is the difference between the Imports (in Local Currency Unit) in Jordan and Imports (in Local Currency Unit) in Kuwait?
Make the answer very short. 1.00e+09. In the year 2004, what is the difference between the Imports (in Local Currency Unit) in Jordan and Imports (in Local Currency Unit) in Tajikistan?
Offer a very short reply. 2.37e+09. In the year 2004, what is the difference between the Imports (in Local Currency Unit) in Kuwait and Imports (in Local Currency Unit) in Tajikistan?
Your answer should be very brief. 1.36e+09. In the year 2005, what is the difference between the Imports (in Local Currency Unit) of Haiti and Imports (in Local Currency Unit) of Jordan?
Your answer should be very brief. 6.37e+1. In the year 2005, what is the difference between the Imports (in Local Currency Unit) of Haiti and Imports (in Local Currency Unit) of Kuwait?
Your answer should be very brief. 6.55e+1. In the year 2005, what is the difference between the Imports (in Local Currency Unit) in Haiti and Imports (in Local Currency Unit) in Tajikistan?
Offer a terse response. 6.83e+1. In the year 2005, what is the difference between the Imports (in Local Currency Unit) of Jordan and Imports (in Local Currency Unit) of Kuwait?
Make the answer very short. 1.74e+09. In the year 2005, what is the difference between the Imports (in Local Currency Unit) in Jordan and Imports (in Local Currency Unit) in Tajikistan?
Provide a short and direct response. 4.60e+09. In the year 2005, what is the difference between the Imports (in Local Currency Unit) of Kuwait and Imports (in Local Currency Unit) of Tajikistan?
Your response must be concise. 2.86e+09. In the year 2006, what is the difference between the Imports (in Local Currency Unit) of Haiti and Imports (in Local Currency Unit) of Jordan?
Provide a short and direct response. 7.94e+1. In the year 2006, what is the difference between the Imports (in Local Currency Unit) in Haiti and Imports (in Local Currency Unit) in Kuwait?
Make the answer very short. 8.16e+1. In the year 2006, what is the difference between the Imports (in Local Currency Unit) in Haiti and Imports (in Local Currency Unit) in Tajikistan?
Offer a very short reply. 8.34e+1. In the year 2006, what is the difference between the Imports (in Local Currency Unit) of Jordan and Imports (in Local Currency Unit) of Kuwait?
Your answer should be very brief. 2.26e+09. In the year 2006, what is the difference between the Imports (in Local Currency Unit) in Jordan and Imports (in Local Currency Unit) in Tajikistan?
Give a very brief answer. 4.05e+09. In the year 2006, what is the difference between the Imports (in Local Currency Unit) in Kuwait and Imports (in Local Currency Unit) in Tajikistan?
Offer a terse response. 1.79e+09. In the year 2007, what is the difference between the Imports (in Local Currency Unit) in Haiti and Imports (in Local Currency Unit) in Jordan?
Offer a terse response. 7.46e+1. In the year 2007, what is the difference between the Imports (in Local Currency Unit) of Haiti and Imports (in Local Currency Unit) of Kuwait?
Offer a terse response. 7.65e+1. In the year 2007, what is the difference between the Imports (in Local Currency Unit) of Haiti and Imports (in Local Currency Unit) of Tajikistan?
Your answer should be very brief. 7.69e+1. In the year 2007, what is the difference between the Imports (in Local Currency Unit) of Jordan and Imports (in Local Currency Unit) of Kuwait?
Provide a succinct answer. 1.91e+09. In the year 2007, what is the difference between the Imports (in Local Currency Unit) of Jordan and Imports (in Local Currency Unit) of Tajikistan?
Keep it short and to the point. 2.34e+09. In the year 2007, what is the difference between the Imports (in Local Currency Unit) in Kuwait and Imports (in Local Currency Unit) in Tajikistan?
Ensure brevity in your answer.  4.31e+08. In the year 2008, what is the difference between the Imports (in Local Currency Unit) of Haiti and Imports (in Local Currency Unit) of Jordan?
Provide a short and direct response. 9.71e+1. In the year 2008, what is the difference between the Imports (in Local Currency Unit) of Haiti and Imports (in Local Currency Unit) of Kuwait?
Your answer should be compact. 1.00e+11. In the year 2008, what is the difference between the Imports (in Local Currency Unit) of Haiti and Imports (in Local Currency Unit) of Tajikistan?
Your answer should be very brief. 9.80e+1. In the year 2008, what is the difference between the Imports (in Local Currency Unit) of Jordan and Imports (in Local Currency Unit) of Kuwait?
Ensure brevity in your answer.  3.38e+09. In the year 2008, what is the difference between the Imports (in Local Currency Unit) of Jordan and Imports (in Local Currency Unit) of Tajikistan?
Your response must be concise. 9.39e+08. In the year 2008, what is the difference between the Imports (in Local Currency Unit) in Kuwait and Imports (in Local Currency Unit) in Tajikistan?
Offer a very short reply. -2.44e+09. What is the ratio of the Imports (in Local Currency Unit) of Haiti in 2002 to that in 2003?
Your answer should be compact. 0.59. What is the ratio of the Imports (in Local Currency Unit) of Jordan in 2002 to that in 2003?
Offer a very short reply. 0.92. What is the ratio of the Imports (in Local Currency Unit) of Kuwait in 2002 to that in 2003?
Offer a terse response. 0.86. What is the ratio of the Imports (in Local Currency Unit) in Tajikistan in 2002 to that in 2003?
Your answer should be very brief. 0.73. What is the ratio of the Imports (in Local Currency Unit) of Haiti in 2002 to that in 2004?
Offer a very short reply. 0.55. What is the ratio of the Imports (in Local Currency Unit) of Jordan in 2002 to that in 2004?
Ensure brevity in your answer.  0.68. What is the ratio of the Imports (in Local Currency Unit) of Kuwait in 2002 to that in 2004?
Give a very brief answer. 0.75. What is the ratio of the Imports (in Local Currency Unit) of Tajikistan in 2002 to that in 2004?
Offer a very short reply. 0.6. What is the ratio of the Imports (in Local Currency Unit) in Haiti in 2002 to that in 2005?
Your answer should be very brief. 0.47. What is the ratio of the Imports (in Local Currency Unit) in Jordan in 2002 to that in 2005?
Make the answer very short. 0.54. What is the ratio of the Imports (in Local Currency Unit) in Kuwait in 2002 to that in 2005?
Your response must be concise. 0.64. What is the ratio of the Imports (in Local Currency Unit) of Tajikistan in 2002 to that in 2005?
Your answer should be compact. 0.68. What is the ratio of the Imports (in Local Currency Unit) of Haiti in 2002 to that in 2006?
Your answer should be compact. 0.38. What is the ratio of the Imports (in Local Currency Unit) in Jordan in 2002 to that in 2006?
Offer a terse response. 0.48. What is the ratio of the Imports (in Local Currency Unit) in Kuwait in 2002 to that in 2006?
Provide a succinct answer. 0.6. What is the ratio of the Imports (in Local Currency Unit) of Tajikistan in 2002 to that in 2006?
Make the answer very short. 0.48. What is the ratio of the Imports (in Local Currency Unit) in Haiti in 2002 to that in 2007?
Keep it short and to the point. 0.39. What is the ratio of the Imports (in Local Currency Unit) in Jordan in 2002 to that in 2007?
Your answer should be very brief. 0.41. What is the ratio of the Imports (in Local Currency Unit) in Kuwait in 2002 to that in 2007?
Provide a short and direct response. 0.46. What is the ratio of the Imports (in Local Currency Unit) in Tajikistan in 2002 to that in 2007?
Your response must be concise. 0.29. What is the ratio of the Imports (in Local Currency Unit) in Haiti in 2002 to that in 2008?
Make the answer very short. 0.31. What is the ratio of the Imports (in Local Currency Unit) of Jordan in 2002 to that in 2008?
Ensure brevity in your answer.  0.33. What is the ratio of the Imports (in Local Currency Unit) of Kuwait in 2002 to that in 2008?
Give a very brief answer. 0.41. What is the ratio of the Imports (in Local Currency Unit) of Tajikistan in 2002 to that in 2008?
Ensure brevity in your answer.  0.2. What is the ratio of the Imports (in Local Currency Unit) of Haiti in 2003 to that in 2004?
Ensure brevity in your answer.  0.93. What is the ratio of the Imports (in Local Currency Unit) in Jordan in 2003 to that in 2004?
Your response must be concise. 0.74. What is the ratio of the Imports (in Local Currency Unit) of Kuwait in 2003 to that in 2004?
Offer a very short reply. 0.87. What is the ratio of the Imports (in Local Currency Unit) of Tajikistan in 2003 to that in 2004?
Give a very brief answer. 0.81. What is the ratio of the Imports (in Local Currency Unit) in Haiti in 2003 to that in 2005?
Offer a very short reply. 0.79. What is the ratio of the Imports (in Local Currency Unit) in Jordan in 2003 to that in 2005?
Ensure brevity in your answer.  0.59. What is the ratio of the Imports (in Local Currency Unit) in Kuwait in 2003 to that in 2005?
Offer a very short reply. 0.74. What is the ratio of the Imports (in Local Currency Unit) in Tajikistan in 2003 to that in 2005?
Your answer should be compact. 0.92. What is the ratio of the Imports (in Local Currency Unit) of Haiti in 2003 to that in 2006?
Offer a terse response. 0.65. What is the ratio of the Imports (in Local Currency Unit) in Jordan in 2003 to that in 2006?
Make the answer very short. 0.53. What is the ratio of the Imports (in Local Currency Unit) of Kuwait in 2003 to that in 2006?
Provide a succinct answer. 0.69. What is the ratio of the Imports (in Local Currency Unit) of Tajikistan in 2003 to that in 2006?
Your answer should be very brief. 0.66. What is the ratio of the Imports (in Local Currency Unit) of Haiti in 2003 to that in 2007?
Keep it short and to the point. 0.67. What is the ratio of the Imports (in Local Currency Unit) of Jordan in 2003 to that in 2007?
Your answer should be compact. 0.44. What is the ratio of the Imports (in Local Currency Unit) of Kuwait in 2003 to that in 2007?
Provide a succinct answer. 0.53. What is the ratio of the Imports (in Local Currency Unit) of Tajikistan in 2003 to that in 2007?
Offer a terse response. 0.4. What is the ratio of the Imports (in Local Currency Unit) of Haiti in 2003 to that in 2008?
Your response must be concise. 0.52. What is the ratio of the Imports (in Local Currency Unit) in Jordan in 2003 to that in 2008?
Ensure brevity in your answer.  0.36. What is the ratio of the Imports (in Local Currency Unit) in Kuwait in 2003 to that in 2008?
Provide a short and direct response. 0.48. What is the ratio of the Imports (in Local Currency Unit) of Tajikistan in 2003 to that in 2008?
Keep it short and to the point. 0.28. What is the ratio of the Imports (in Local Currency Unit) of Haiti in 2004 to that in 2005?
Your answer should be very brief. 0.86. What is the ratio of the Imports (in Local Currency Unit) in Jordan in 2004 to that in 2005?
Make the answer very short. 0.79. What is the ratio of the Imports (in Local Currency Unit) in Kuwait in 2004 to that in 2005?
Provide a succinct answer. 0.85. What is the ratio of the Imports (in Local Currency Unit) in Tajikistan in 2004 to that in 2005?
Offer a very short reply. 1.13. What is the ratio of the Imports (in Local Currency Unit) in Haiti in 2004 to that in 2006?
Your response must be concise. 0.7. What is the ratio of the Imports (in Local Currency Unit) of Jordan in 2004 to that in 2006?
Provide a succinct answer. 0.71. What is the ratio of the Imports (in Local Currency Unit) of Kuwait in 2004 to that in 2006?
Your answer should be compact. 0.8. What is the ratio of the Imports (in Local Currency Unit) in Tajikistan in 2004 to that in 2006?
Offer a very short reply. 0.81. What is the ratio of the Imports (in Local Currency Unit) in Haiti in 2004 to that in 2007?
Offer a very short reply. 0.72. What is the ratio of the Imports (in Local Currency Unit) of Jordan in 2004 to that in 2007?
Ensure brevity in your answer.  0.6. What is the ratio of the Imports (in Local Currency Unit) in Kuwait in 2004 to that in 2007?
Your answer should be compact. 0.61. What is the ratio of the Imports (in Local Currency Unit) in Tajikistan in 2004 to that in 2007?
Provide a succinct answer. 0.49. What is the ratio of the Imports (in Local Currency Unit) of Haiti in 2004 to that in 2008?
Ensure brevity in your answer.  0.56. What is the ratio of the Imports (in Local Currency Unit) of Jordan in 2004 to that in 2008?
Provide a succinct answer. 0.49. What is the ratio of the Imports (in Local Currency Unit) in Kuwait in 2004 to that in 2008?
Make the answer very short. 0.55. What is the ratio of the Imports (in Local Currency Unit) of Tajikistan in 2004 to that in 2008?
Provide a short and direct response. 0.34. What is the ratio of the Imports (in Local Currency Unit) of Haiti in 2005 to that in 2006?
Your answer should be very brief. 0.81. What is the ratio of the Imports (in Local Currency Unit) in Jordan in 2005 to that in 2006?
Make the answer very short. 0.9. What is the ratio of the Imports (in Local Currency Unit) in Kuwait in 2005 to that in 2006?
Your answer should be compact. 0.94. What is the ratio of the Imports (in Local Currency Unit) in Tajikistan in 2005 to that in 2006?
Provide a succinct answer. 0.71. What is the ratio of the Imports (in Local Currency Unit) of Haiti in 2005 to that in 2007?
Provide a succinct answer. 0.84. What is the ratio of the Imports (in Local Currency Unit) of Jordan in 2005 to that in 2007?
Keep it short and to the point. 0.76. What is the ratio of the Imports (in Local Currency Unit) of Kuwait in 2005 to that in 2007?
Keep it short and to the point. 0.72. What is the ratio of the Imports (in Local Currency Unit) of Tajikistan in 2005 to that in 2007?
Provide a succinct answer. 0.43. What is the ratio of the Imports (in Local Currency Unit) of Haiti in 2005 to that in 2008?
Keep it short and to the point. 0.65. What is the ratio of the Imports (in Local Currency Unit) of Jordan in 2005 to that in 2008?
Give a very brief answer. 0.62. What is the ratio of the Imports (in Local Currency Unit) of Kuwait in 2005 to that in 2008?
Keep it short and to the point. 0.65. What is the ratio of the Imports (in Local Currency Unit) in Tajikistan in 2005 to that in 2008?
Give a very brief answer. 0.3. What is the ratio of the Imports (in Local Currency Unit) in Haiti in 2006 to that in 2007?
Offer a very short reply. 1.04. What is the ratio of the Imports (in Local Currency Unit) of Jordan in 2006 to that in 2007?
Provide a succinct answer. 0.84. What is the ratio of the Imports (in Local Currency Unit) of Kuwait in 2006 to that in 2007?
Offer a very short reply. 0.77. What is the ratio of the Imports (in Local Currency Unit) of Tajikistan in 2006 to that in 2007?
Offer a terse response. 0.61. What is the ratio of the Imports (in Local Currency Unit) in Haiti in 2006 to that in 2008?
Your answer should be compact. 0.8. What is the ratio of the Imports (in Local Currency Unit) of Jordan in 2006 to that in 2008?
Your answer should be very brief. 0.69. What is the ratio of the Imports (in Local Currency Unit) of Kuwait in 2006 to that in 2008?
Ensure brevity in your answer.  0.69. What is the ratio of the Imports (in Local Currency Unit) of Tajikistan in 2006 to that in 2008?
Your response must be concise. 0.42. What is the ratio of the Imports (in Local Currency Unit) of Haiti in 2007 to that in 2008?
Your answer should be compact. 0.77. What is the ratio of the Imports (in Local Currency Unit) of Jordan in 2007 to that in 2008?
Your response must be concise. 0.82. What is the ratio of the Imports (in Local Currency Unit) of Kuwait in 2007 to that in 2008?
Offer a very short reply. 0.9. What is the ratio of the Imports (in Local Currency Unit) of Tajikistan in 2007 to that in 2008?
Keep it short and to the point. 0.69. What is the difference between the highest and the second highest Imports (in Local Currency Unit) of Haiti?
Give a very brief answer. 2.20e+1. What is the difference between the highest and the second highest Imports (in Local Currency Unit) of Jordan?
Your answer should be compact. 2.51e+09. What is the difference between the highest and the second highest Imports (in Local Currency Unit) of Kuwait?
Provide a succinct answer. 1.04e+09. What is the difference between the highest and the second highest Imports (in Local Currency Unit) in Tajikistan?
Your response must be concise. 3.91e+09. What is the difference between the highest and the lowest Imports (in Local Currency Unit) of Haiti?
Offer a very short reply. 7.69e+1. What is the difference between the highest and the lowest Imports (in Local Currency Unit) in Jordan?
Offer a very short reply. 9.11e+09. What is the difference between the highest and the lowest Imports (in Local Currency Unit) in Kuwait?
Provide a succinct answer. 6.03e+09. What is the difference between the highest and the lowest Imports (in Local Currency Unit) of Tajikistan?
Give a very brief answer. 1.01e+1. 